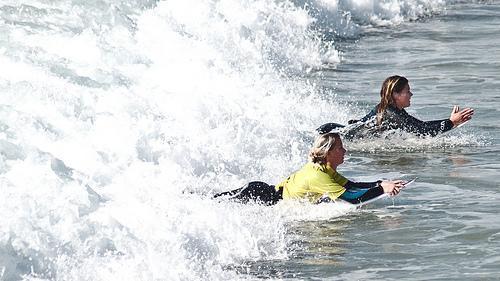How many people are in the water?
Give a very brief answer. 2. 